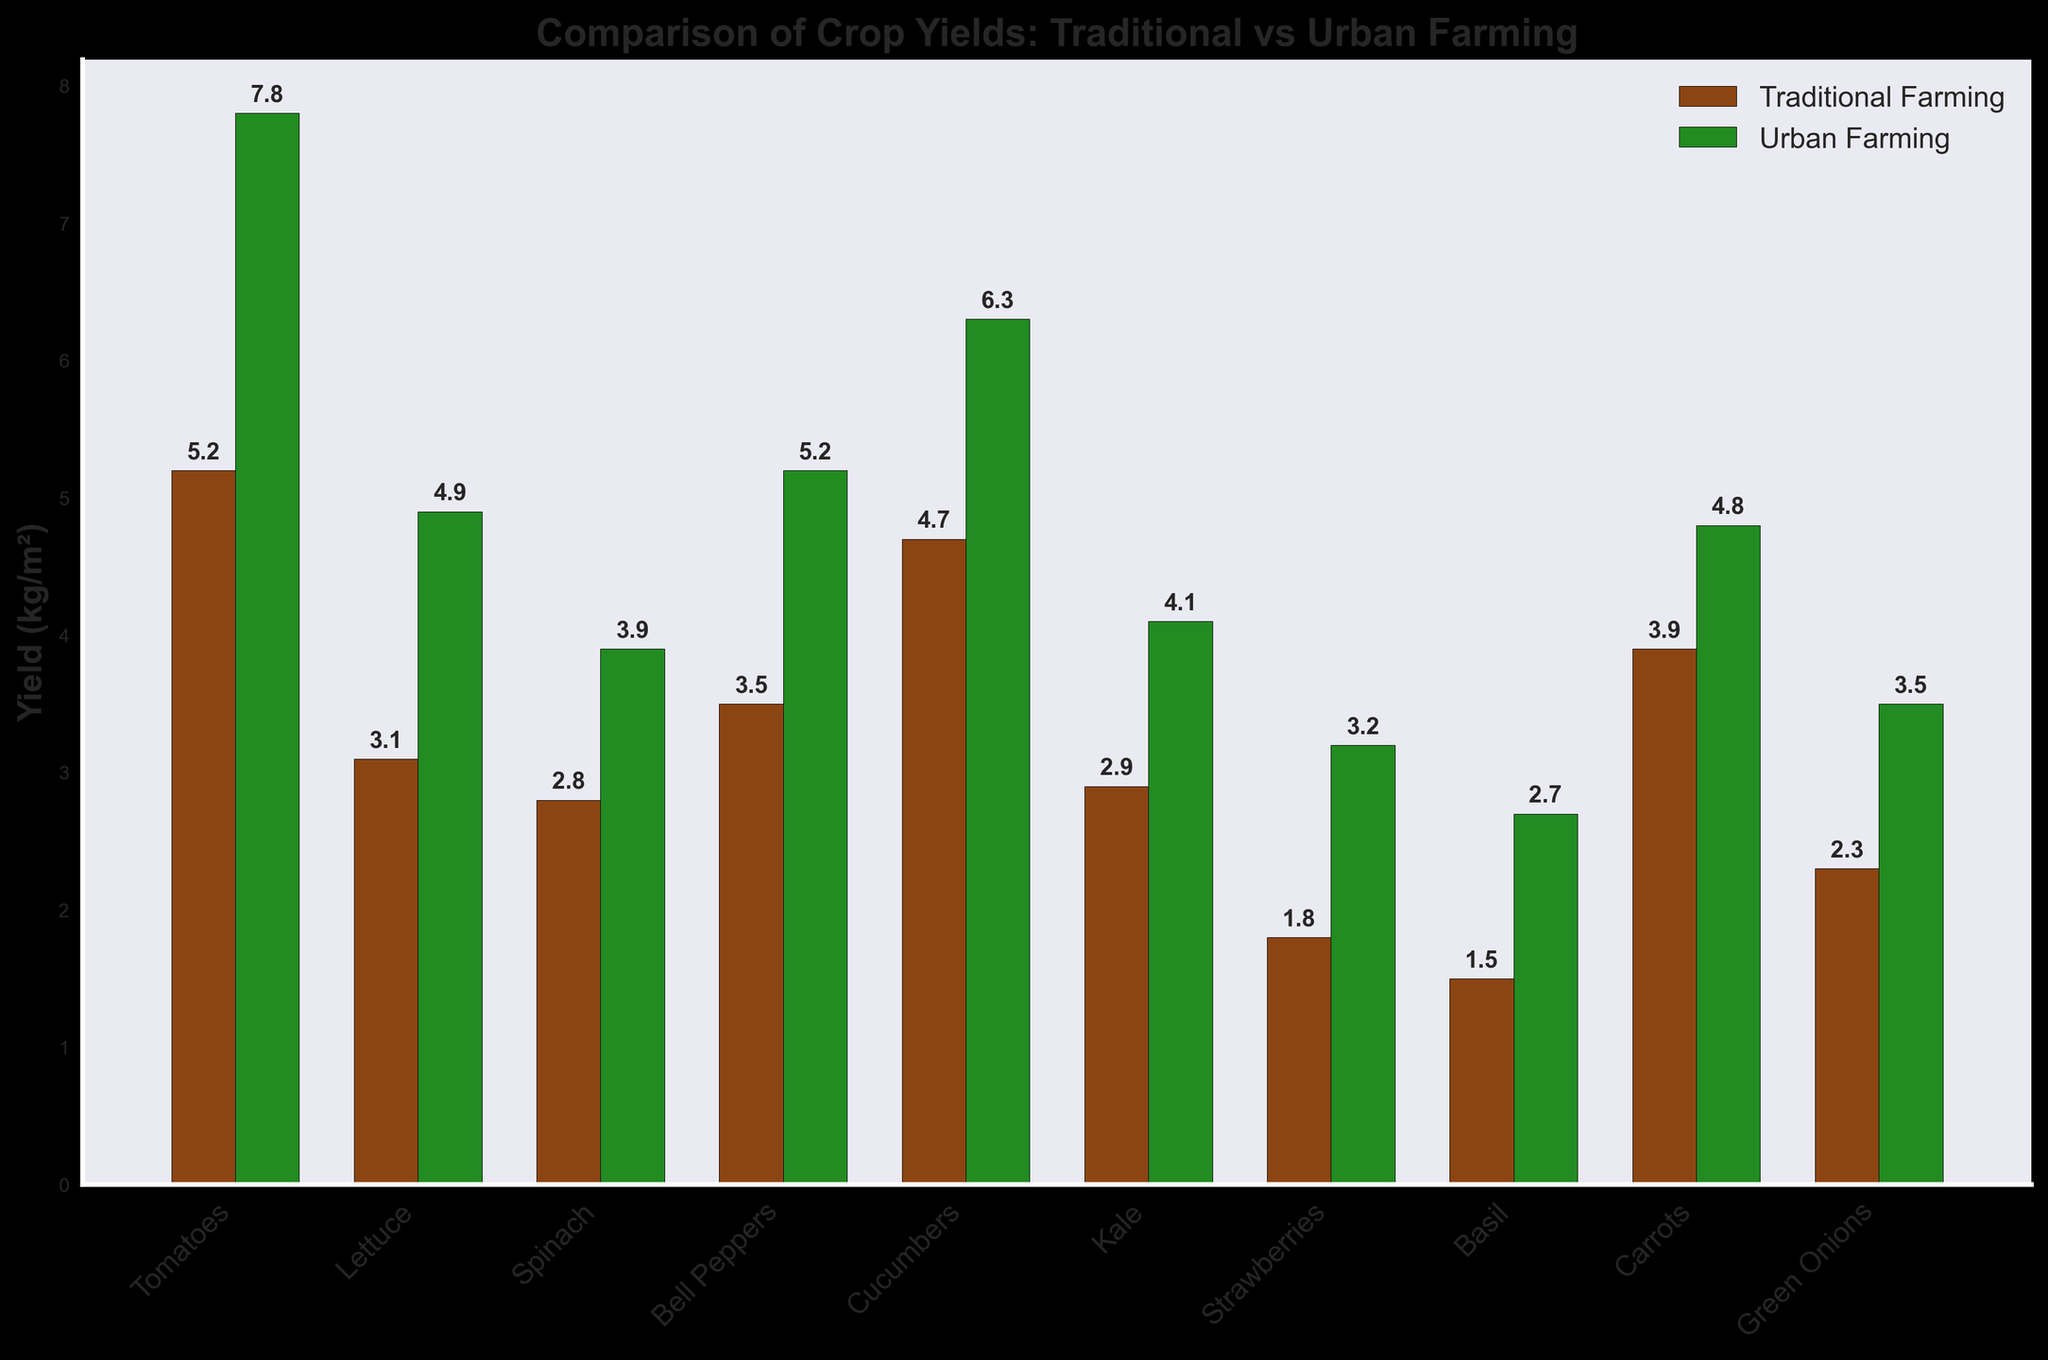What's the average yield of Urban Farming for Tomatoes, Lettuce, and Spinach? Sum the yields of Urban Farming for Tomatoes (7.8 kg/m²), Lettuce (4.9 kg/m²), and Spinach (3.9 kg/m²), which is 7.8 + 4.9 + 3.9 = 16.6 kg/m². Then, divide by the number of crops, which is 3. The average yield is 16.6 / 3 ≈ 5.53 kg/m².
Answer: 5.53 kg/m² Which method produces a higher yield for Strawberries and by how much? The yield for Strawberries is 1.8 kg/m² for Traditional Farming and 3.2 kg/m² for Urban Farming. Subtract 1.8 from 3.2 to find the difference: 3.2 - 1.8 = 1.4 kg/m².
Answer: Urban Farming by 1.4 kg/m² For which crop does Urban Farming provide the smallest yield advantage over Traditional Farming? Calculate the difference between Urban and Traditional yields for each crop, then identify the smallest difference. Kale has Traditional yield of 2.9 kg/m² and Urban yield of 4.1 kg/m², making the difference 4.1 - 2.9 = 1.2 kg/m², which is the smallest among all crops.
Answer: Kale In how many crops does Urban Farming yield at least 50% more than Traditional Farming? Calculate the yield difference percentage for each crop. A 50% increase means Urban yield should be at least 1.5 times the Traditional yield. Tomatoes (7.8/5.2 ≈ 1.5), Lettuce (4.9/3.1 ≈ 1.58), Bell Peppers (5.2/3.5 ≈ 1.49 - slightly less than 50%), Cucumbers (6.3/4.7 ≈ 1.34 - less than 50%), Kale (4.1/2.9 ≈ 1.41 - less than 50%), Strawberries (3.2/1.8 ≈ 1.78), Basil (2.7/1.5 ≈ 1.8), Green Onions (3.5/2.3 ≈ 1.52). So, Tomatoes, Lettuce, Strawberries, Basil, and Green Onions qualify.
Answer: 5 crops What is the total yield of both farming methods for all crops combined? Sum the yields of both methods for all crops. Traditional total: 5.2 + 3.1 + 2.8 + 3.5 + 4.7 + 2.9 + 1.8 + 1.5 + 3.9 + 2.3 = 31.7 kg/m². Urban total: 7.8 + 4.9 + 3.9 + 5.2 + 6.3 + 4.1 + 3.2 + 2.7 + 4.8 + 3.5 = 46.4 kg/m². Combine the sums: 31.7 + 46.4 = 78.1 kg/m².
Answer: 78.1 kg/m² 